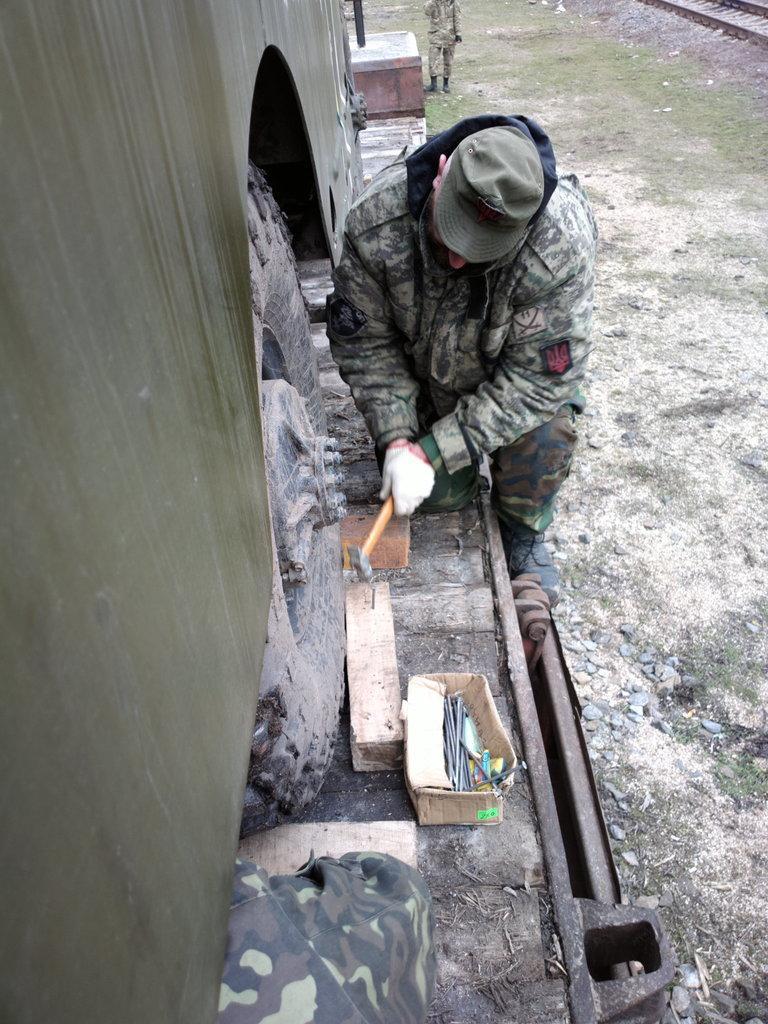How would you summarize this image in a sentence or two? In this image we can see some person wearing army dress, crouching down doing some work holding hammer in his hands, we can see bus wheel and there are some objects on the ground and in the background of the image there is a railway track. 